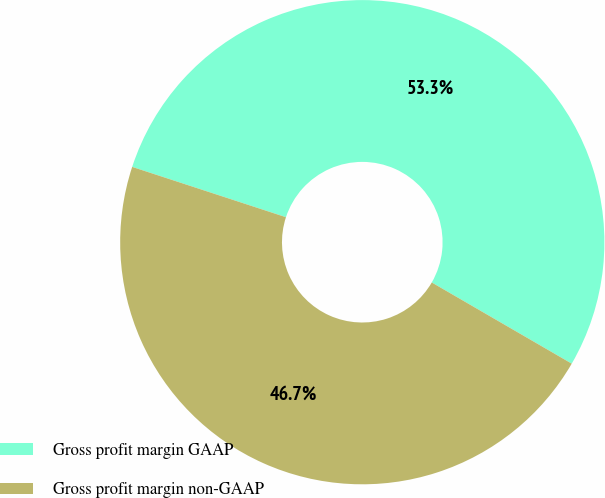<chart> <loc_0><loc_0><loc_500><loc_500><pie_chart><fcel>Gross profit margin GAAP<fcel>Gross profit margin non-GAAP<nl><fcel>53.33%<fcel>46.67%<nl></chart> 